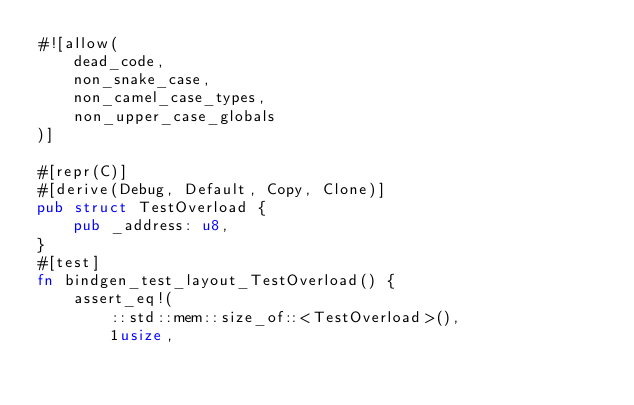Convert code to text. <code><loc_0><loc_0><loc_500><loc_500><_Rust_>#![allow(
    dead_code,
    non_snake_case,
    non_camel_case_types,
    non_upper_case_globals
)]

#[repr(C)]
#[derive(Debug, Default, Copy, Clone)]
pub struct TestOverload {
    pub _address: u8,
}
#[test]
fn bindgen_test_layout_TestOverload() {
    assert_eq!(
        ::std::mem::size_of::<TestOverload>(),
        1usize,</code> 